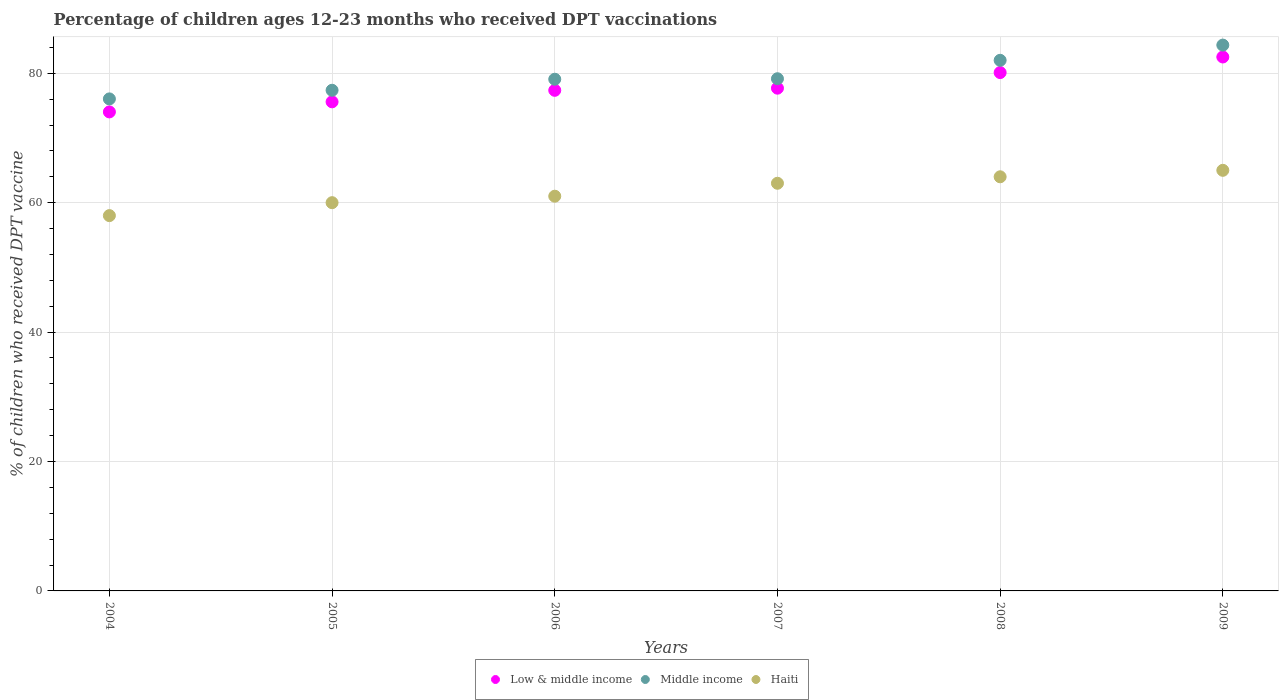What is the percentage of children who received DPT vaccination in Haiti in 2005?
Your response must be concise. 60. Across all years, what is the maximum percentage of children who received DPT vaccination in Middle income?
Your response must be concise. 84.35. Across all years, what is the minimum percentage of children who received DPT vaccination in Low & middle income?
Give a very brief answer. 74.03. In which year was the percentage of children who received DPT vaccination in Low & middle income maximum?
Offer a very short reply. 2009. What is the total percentage of children who received DPT vaccination in Middle income in the graph?
Ensure brevity in your answer.  477.99. What is the difference between the percentage of children who received DPT vaccination in Haiti in 2004 and that in 2007?
Provide a succinct answer. -5. What is the difference between the percentage of children who received DPT vaccination in Middle income in 2004 and the percentage of children who received DPT vaccination in Haiti in 2009?
Offer a very short reply. 11.04. What is the average percentage of children who received DPT vaccination in Middle income per year?
Provide a succinct answer. 79.67. In the year 2004, what is the difference between the percentage of children who received DPT vaccination in Low & middle income and percentage of children who received DPT vaccination in Haiti?
Keep it short and to the point. 16.03. In how many years, is the percentage of children who received DPT vaccination in Haiti greater than 28 %?
Ensure brevity in your answer.  6. What is the ratio of the percentage of children who received DPT vaccination in Low & middle income in 2007 to that in 2009?
Your response must be concise. 0.94. What is the difference between the highest and the lowest percentage of children who received DPT vaccination in Haiti?
Your response must be concise. 7. Is the sum of the percentage of children who received DPT vaccination in Low & middle income in 2004 and 2009 greater than the maximum percentage of children who received DPT vaccination in Middle income across all years?
Your answer should be very brief. Yes. Does the percentage of children who received DPT vaccination in Middle income monotonically increase over the years?
Your answer should be compact. Yes. How many years are there in the graph?
Provide a succinct answer. 6. Are the values on the major ticks of Y-axis written in scientific E-notation?
Give a very brief answer. No. Does the graph contain any zero values?
Keep it short and to the point. No. Where does the legend appear in the graph?
Your answer should be very brief. Bottom center. What is the title of the graph?
Offer a terse response. Percentage of children ages 12-23 months who received DPT vaccinations. Does "New Caledonia" appear as one of the legend labels in the graph?
Provide a short and direct response. No. What is the label or title of the X-axis?
Your answer should be compact. Years. What is the label or title of the Y-axis?
Your response must be concise. % of children who received DPT vaccine. What is the % of children who received DPT vaccine of Low & middle income in 2004?
Keep it short and to the point. 74.03. What is the % of children who received DPT vaccine of Middle income in 2004?
Ensure brevity in your answer.  76.04. What is the % of children who received DPT vaccine of Haiti in 2004?
Offer a very short reply. 58. What is the % of children who received DPT vaccine in Low & middle income in 2005?
Your answer should be compact. 75.58. What is the % of children who received DPT vaccine of Middle income in 2005?
Your answer should be compact. 77.37. What is the % of children who received DPT vaccine of Haiti in 2005?
Offer a very short reply. 60. What is the % of children who received DPT vaccine in Low & middle income in 2006?
Ensure brevity in your answer.  77.36. What is the % of children who received DPT vaccine of Middle income in 2006?
Your response must be concise. 79.08. What is the % of children who received DPT vaccine in Low & middle income in 2007?
Provide a short and direct response. 77.7. What is the % of children who received DPT vaccine in Middle income in 2007?
Give a very brief answer. 79.15. What is the % of children who received DPT vaccine of Low & middle income in 2008?
Keep it short and to the point. 80.11. What is the % of children who received DPT vaccine in Middle income in 2008?
Keep it short and to the point. 82. What is the % of children who received DPT vaccine in Haiti in 2008?
Keep it short and to the point. 64. What is the % of children who received DPT vaccine of Low & middle income in 2009?
Offer a terse response. 82.52. What is the % of children who received DPT vaccine in Middle income in 2009?
Your response must be concise. 84.35. Across all years, what is the maximum % of children who received DPT vaccine in Low & middle income?
Provide a succinct answer. 82.52. Across all years, what is the maximum % of children who received DPT vaccine in Middle income?
Offer a very short reply. 84.35. Across all years, what is the maximum % of children who received DPT vaccine of Haiti?
Make the answer very short. 65. Across all years, what is the minimum % of children who received DPT vaccine in Low & middle income?
Your answer should be very brief. 74.03. Across all years, what is the minimum % of children who received DPT vaccine in Middle income?
Provide a short and direct response. 76.04. What is the total % of children who received DPT vaccine of Low & middle income in the graph?
Give a very brief answer. 467.29. What is the total % of children who received DPT vaccine in Middle income in the graph?
Offer a very short reply. 477.99. What is the total % of children who received DPT vaccine in Haiti in the graph?
Offer a terse response. 371. What is the difference between the % of children who received DPT vaccine of Low & middle income in 2004 and that in 2005?
Keep it short and to the point. -1.56. What is the difference between the % of children who received DPT vaccine of Middle income in 2004 and that in 2005?
Keep it short and to the point. -1.33. What is the difference between the % of children who received DPT vaccine in Low & middle income in 2004 and that in 2006?
Make the answer very short. -3.34. What is the difference between the % of children who received DPT vaccine in Middle income in 2004 and that in 2006?
Give a very brief answer. -3.04. What is the difference between the % of children who received DPT vaccine in Haiti in 2004 and that in 2006?
Offer a very short reply. -3. What is the difference between the % of children who received DPT vaccine of Low & middle income in 2004 and that in 2007?
Keep it short and to the point. -3.67. What is the difference between the % of children who received DPT vaccine of Middle income in 2004 and that in 2007?
Provide a succinct answer. -3.12. What is the difference between the % of children who received DPT vaccine of Low & middle income in 2004 and that in 2008?
Provide a short and direct response. -6.08. What is the difference between the % of children who received DPT vaccine of Middle income in 2004 and that in 2008?
Provide a succinct answer. -5.96. What is the difference between the % of children who received DPT vaccine in Low & middle income in 2004 and that in 2009?
Your answer should be compact. -8.49. What is the difference between the % of children who received DPT vaccine of Middle income in 2004 and that in 2009?
Give a very brief answer. -8.31. What is the difference between the % of children who received DPT vaccine in Low & middle income in 2005 and that in 2006?
Offer a very short reply. -1.78. What is the difference between the % of children who received DPT vaccine of Middle income in 2005 and that in 2006?
Make the answer very short. -1.7. What is the difference between the % of children who received DPT vaccine of Haiti in 2005 and that in 2006?
Your response must be concise. -1. What is the difference between the % of children who received DPT vaccine in Low & middle income in 2005 and that in 2007?
Give a very brief answer. -2.11. What is the difference between the % of children who received DPT vaccine in Middle income in 2005 and that in 2007?
Give a very brief answer. -1.78. What is the difference between the % of children who received DPT vaccine of Low & middle income in 2005 and that in 2008?
Give a very brief answer. -4.52. What is the difference between the % of children who received DPT vaccine of Middle income in 2005 and that in 2008?
Ensure brevity in your answer.  -4.63. What is the difference between the % of children who received DPT vaccine in Haiti in 2005 and that in 2008?
Your answer should be very brief. -4. What is the difference between the % of children who received DPT vaccine in Low & middle income in 2005 and that in 2009?
Your response must be concise. -6.93. What is the difference between the % of children who received DPT vaccine of Middle income in 2005 and that in 2009?
Provide a succinct answer. -6.98. What is the difference between the % of children who received DPT vaccine in Low & middle income in 2006 and that in 2007?
Provide a short and direct response. -0.33. What is the difference between the % of children who received DPT vaccine of Middle income in 2006 and that in 2007?
Your response must be concise. -0.08. What is the difference between the % of children who received DPT vaccine in Low & middle income in 2006 and that in 2008?
Keep it short and to the point. -2.74. What is the difference between the % of children who received DPT vaccine of Middle income in 2006 and that in 2008?
Provide a succinct answer. -2.92. What is the difference between the % of children who received DPT vaccine in Haiti in 2006 and that in 2008?
Give a very brief answer. -3. What is the difference between the % of children who received DPT vaccine of Low & middle income in 2006 and that in 2009?
Ensure brevity in your answer.  -5.15. What is the difference between the % of children who received DPT vaccine of Middle income in 2006 and that in 2009?
Your answer should be very brief. -5.28. What is the difference between the % of children who received DPT vaccine of Low & middle income in 2007 and that in 2008?
Offer a very short reply. -2.41. What is the difference between the % of children who received DPT vaccine in Middle income in 2007 and that in 2008?
Your answer should be compact. -2.85. What is the difference between the % of children who received DPT vaccine of Low & middle income in 2007 and that in 2009?
Keep it short and to the point. -4.82. What is the difference between the % of children who received DPT vaccine in Middle income in 2007 and that in 2009?
Offer a terse response. -5.2. What is the difference between the % of children who received DPT vaccine in Low & middle income in 2008 and that in 2009?
Make the answer very short. -2.41. What is the difference between the % of children who received DPT vaccine of Middle income in 2008 and that in 2009?
Keep it short and to the point. -2.35. What is the difference between the % of children who received DPT vaccine in Low & middle income in 2004 and the % of children who received DPT vaccine in Middle income in 2005?
Your answer should be very brief. -3.35. What is the difference between the % of children who received DPT vaccine of Low & middle income in 2004 and the % of children who received DPT vaccine of Haiti in 2005?
Offer a terse response. 14.03. What is the difference between the % of children who received DPT vaccine of Middle income in 2004 and the % of children who received DPT vaccine of Haiti in 2005?
Provide a short and direct response. 16.04. What is the difference between the % of children who received DPT vaccine of Low & middle income in 2004 and the % of children who received DPT vaccine of Middle income in 2006?
Keep it short and to the point. -5.05. What is the difference between the % of children who received DPT vaccine in Low & middle income in 2004 and the % of children who received DPT vaccine in Haiti in 2006?
Offer a very short reply. 13.03. What is the difference between the % of children who received DPT vaccine in Middle income in 2004 and the % of children who received DPT vaccine in Haiti in 2006?
Your answer should be very brief. 15.04. What is the difference between the % of children who received DPT vaccine of Low & middle income in 2004 and the % of children who received DPT vaccine of Middle income in 2007?
Ensure brevity in your answer.  -5.13. What is the difference between the % of children who received DPT vaccine of Low & middle income in 2004 and the % of children who received DPT vaccine of Haiti in 2007?
Ensure brevity in your answer.  11.03. What is the difference between the % of children who received DPT vaccine of Middle income in 2004 and the % of children who received DPT vaccine of Haiti in 2007?
Offer a very short reply. 13.04. What is the difference between the % of children who received DPT vaccine of Low & middle income in 2004 and the % of children who received DPT vaccine of Middle income in 2008?
Offer a terse response. -7.97. What is the difference between the % of children who received DPT vaccine in Low & middle income in 2004 and the % of children who received DPT vaccine in Haiti in 2008?
Offer a terse response. 10.03. What is the difference between the % of children who received DPT vaccine in Middle income in 2004 and the % of children who received DPT vaccine in Haiti in 2008?
Keep it short and to the point. 12.04. What is the difference between the % of children who received DPT vaccine in Low & middle income in 2004 and the % of children who received DPT vaccine in Middle income in 2009?
Offer a terse response. -10.33. What is the difference between the % of children who received DPT vaccine of Low & middle income in 2004 and the % of children who received DPT vaccine of Haiti in 2009?
Give a very brief answer. 9.03. What is the difference between the % of children who received DPT vaccine in Middle income in 2004 and the % of children who received DPT vaccine in Haiti in 2009?
Give a very brief answer. 11.04. What is the difference between the % of children who received DPT vaccine in Low & middle income in 2005 and the % of children who received DPT vaccine in Middle income in 2006?
Make the answer very short. -3.49. What is the difference between the % of children who received DPT vaccine of Low & middle income in 2005 and the % of children who received DPT vaccine of Haiti in 2006?
Your response must be concise. 14.58. What is the difference between the % of children who received DPT vaccine in Middle income in 2005 and the % of children who received DPT vaccine in Haiti in 2006?
Offer a terse response. 16.37. What is the difference between the % of children who received DPT vaccine of Low & middle income in 2005 and the % of children who received DPT vaccine of Middle income in 2007?
Your response must be concise. -3.57. What is the difference between the % of children who received DPT vaccine of Low & middle income in 2005 and the % of children who received DPT vaccine of Haiti in 2007?
Provide a succinct answer. 12.58. What is the difference between the % of children who received DPT vaccine of Middle income in 2005 and the % of children who received DPT vaccine of Haiti in 2007?
Offer a very short reply. 14.37. What is the difference between the % of children who received DPT vaccine of Low & middle income in 2005 and the % of children who received DPT vaccine of Middle income in 2008?
Offer a very short reply. -6.42. What is the difference between the % of children who received DPT vaccine of Low & middle income in 2005 and the % of children who received DPT vaccine of Haiti in 2008?
Offer a very short reply. 11.58. What is the difference between the % of children who received DPT vaccine of Middle income in 2005 and the % of children who received DPT vaccine of Haiti in 2008?
Your answer should be very brief. 13.37. What is the difference between the % of children who received DPT vaccine in Low & middle income in 2005 and the % of children who received DPT vaccine in Middle income in 2009?
Provide a short and direct response. -8.77. What is the difference between the % of children who received DPT vaccine of Low & middle income in 2005 and the % of children who received DPT vaccine of Haiti in 2009?
Provide a succinct answer. 10.58. What is the difference between the % of children who received DPT vaccine in Middle income in 2005 and the % of children who received DPT vaccine in Haiti in 2009?
Ensure brevity in your answer.  12.37. What is the difference between the % of children who received DPT vaccine of Low & middle income in 2006 and the % of children who received DPT vaccine of Middle income in 2007?
Give a very brief answer. -1.79. What is the difference between the % of children who received DPT vaccine of Low & middle income in 2006 and the % of children who received DPT vaccine of Haiti in 2007?
Give a very brief answer. 14.36. What is the difference between the % of children who received DPT vaccine of Middle income in 2006 and the % of children who received DPT vaccine of Haiti in 2007?
Your response must be concise. 16.08. What is the difference between the % of children who received DPT vaccine of Low & middle income in 2006 and the % of children who received DPT vaccine of Middle income in 2008?
Provide a succinct answer. -4.64. What is the difference between the % of children who received DPT vaccine in Low & middle income in 2006 and the % of children who received DPT vaccine in Haiti in 2008?
Provide a short and direct response. 13.36. What is the difference between the % of children who received DPT vaccine in Middle income in 2006 and the % of children who received DPT vaccine in Haiti in 2008?
Offer a very short reply. 15.08. What is the difference between the % of children who received DPT vaccine in Low & middle income in 2006 and the % of children who received DPT vaccine in Middle income in 2009?
Provide a short and direct response. -6.99. What is the difference between the % of children who received DPT vaccine of Low & middle income in 2006 and the % of children who received DPT vaccine of Haiti in 2009?
Provide a succinct answer. 12.36. What is the difference between the % of children who received DPT vaccine of Middle income in 2006 and the % of children who received DPT vaccine of Haiti in 2009?
Offer a terse response. 14.08. What is the difference between the % of children who received DPT vaccine of Low & middle income in 2007 and the % of children who received DPT vaccine of Middle income in 2008?
Provide a short and direct response. -4.31. What is the difference between the % of children who received DPT vaccine in Low & middle income in 2007 and the % of children who received DPT vaccine in Haiti in 2008?
Make the answer very short. 13.7. What is the difference between the % of children who received DPT vaccine in Middle income in 2007 and the % of children who received DPT vaccine in Haiti in 2008?
Offer a very short reply. 15.15. What is the difference between the % of children who received DPT vaccine in Low & middle income in 2007 and the % of children who received DPT vaccine in Middle income in 2009?
Your answer should be very brief. -6.66. What is the difference between the % of children who received DPT vaccine of Low & middle income in 2007 and the % of children who received DPT vaccine of Haiti in 2009?
Provide a succinct answer. 12.7. What is the difference between the % of children who received DPT vaccine of Middle income in 2007 and the % of children who received DPT vaccine of Haiti in 2009?
Keep it short and to the point. 14.15. What is the difference between the % of children who received DPT vaccine in Low & middle income in 2008 and the % of children who received DPT vaccine in Middle income in 2009?
Offer a terse response. -4.24. What is the difference between the % of children who received DPT vaccine of Low & middle income in 2008 and the % of children who received DPT vaccine of Haiti in 2009?
Provide a succinct answer. 15.11. What is the difference between the % of children who received DPT vaccine of Middle income in 2008 and the % of children who received DPT vaccine of Haiti in 2009?
Keep it short and to the point. 17. What is the average % of children who received DPT vaccine in Low & middle income per year?
Keep it short and to the point. 77.88. What is the average % of children who received DPT vaccine in Middle income per year?
Your response must be concise. 79.67. What is the average % of children who received DPT vaccine in Haiti per year?
Your response must be concise. 61.83. In the year 2004, what is the difference between the % of children who received DPT vaccine of Low & middle income and % of children who received DPT vaccine of Middle income?
Make the answer very short. -2.01. In the year 2004, what is the difference between the % of children who received DPT vaccine of Low & middle income and % of children who received DPT vaccine of Haiti?
Make the answer very short. 16.03. In the year 2004, what is the difference between the % of children who received DPT vaccine in Middle income and % of children who received DPT vaccine in Haiti?
Provide a succinct answer. 18.04. In the year 2005, what is the difference between the % of children who received DPT vaccine of Low & middle income and % of children who received DPT vaccine of Middle income?
Make the answer very short. -1.79. In the year 2005, what is the difference between the % of children who received DPT vaccine of Low & middle income and % of children who received DPT vaccine of Haiti?
Make the answer very short. 15.58. In the year 2005, what is the difference between the % of children who received DPT vaccine of Middle income and % of children who received DPT vaccine of Haiti?
Make the answer very short. 17.37. In the year 2006, what is the difference between the % of children who received DPT vaccine of Low & middle income and % of children who received DPT vaccine of Middle income?
Your response must be concise. -1.71. In the year 2006, what is the difference between the % of children who received DPT vaccine of Low & middle income and % of children who received DPT vaccine of Haiti?
Give a very brief answer. 16.36. In the year 2006, what is the difference between the % of children who received DPT vaccine in Middle income and % of children who received DPT vaccine in Haiti?
Ensure brevity in your answer.  18.08. In the year 2007, what is the difference between the % of children who received DPT vaccine of Low & middle income and % of children who received DPT vaccine of Middle income?
Ensure brevity in your answer.  -1.46. In the year 2007, what is the difference between the % of children who received DPT vaccine of Low & middle income and % of children who received DPT vaccine of Haiti?
Give a very brief answer. 14.7. In the year 2007, what is the difference between the % of children who received DPT vaccine of Middle income and % of children who received DPT vaccine of Haiti?
Give a very brief answer. 16.15. In the year 2008, what is the difference between the % of children who received DPT vaccine in Low & middle income and % of children who received DPT vaccine in Middle income?
Your answer should be compact. -1.89. In the year 2008, what is the difference between the % of children who received DPT vaccine in Low & middle income and % of children who received DPT vaccine in Haiti?
Offer a terse response. 16.11. In the year 2008, what is the difference between the % of children who received DPT vaccine of Middle income and % of children who received DPT vaccine of Haiti?
Offer a terse response. 18. In the year 2009, what is the difference between the % of children who received DPT vaccine of Low & middle income and % of children who received DPT vaccine of Middle income?
Provide a short and direct response. -1.84. In the year 2009, what is the difference between the % of children who received DPT vaccine of Low & middle income and % of children who received DPT vaccine of Haiti?
Offer a very short reply. 17.52. In the year 2009, what is the difference between the % of children who received DPT vaccine of Middle income and % of children who received DPT vaccine of Haiti?
Offer a very short reply. 19.35. What is the ratio of the % of children who received DPT vaccine in Low & middle income in 2004 to that in 2005?
Give a very brief answer. 0.98. What is the ratio of the % of children who received DPT vaccine of Middle income in 2004 to that in 2005?
Keep it short and to the point. 0.98. What is the ratio of the % of children who received DPT vaccine in Haiti in 2004 to that in 2005?
Your response must be concise. 0.97. What is the ratio of the % of children who received DPT vaccine in Low & middle income in 2004 to that in 2006?
Provide a succinct answer. 0.96. What is the ratio of the % of children who received DPT vaccine of Middle income in 2004 to that in 2006?
Ensure brevity in your answer.  0.96. What is the ratio of the % of children who received DPT vaccine in Haiti in 2004 to that in 2006?
Provide a short and direct response. 0.95. What is the ratio of the % of children who received DPT vaccine of Low & middle income in 2004 to that in 2007?
Your answer should be very brief. 0.95. What is the ratio of the % of children who received DPT vaccine in Middle income in 2004 to that in 2007?
Make the answer very short. 0.96. What is the ratio of the % of children who received DPT vaccine of Haiti in 2004 to that in 2007?
Make the answer very short. 0.92. What is the ratio of the % of children who received DPT vaccine of Low & middle income in 2004 to that in 2008?
Ensure brevity in your answer.  0.92. What is the ratio of the % of children who received DPT vaccine in Middle income in 2004 to that in 2008?
Ensure brevity in your answer.  0.93. What is the ratio of the % of children who received DPT vaccine in Haiti in 2004 to that in 2008?
Provide a succinct answer. 0.91. What is the ratio of the % of children who received DPT vaccine in Low & middle income in 2004 to that in 2009?
Your answer should be very brief. 0.9. What is the ratio of the % of children who received DPT vaccine in Middle income in 2004 to that in 2009?
Your answer should be very brief. 0.9. What is the ratio of the % of children who received DPT vaccine of Haiti in 2004 to that in 2009?
Ensure brevity in your answer.  0.89. What is the ratio of the % of children who received DPT vaccine of Low & middle income in 2005 to that in 2006?
Provide a succinct answer. 0.98. What is the ratio of the % of children who received DPT vaccine of Middle income in 2005 to that in 2006?
Your answer should be compact. 0.98. What is the ratio of the % of children who received DPT vaccine of Haiti in 2005 to that in 2006?
Your response must be concise. 0.98. What is the ratio of the % of children who received DPT vaccine of Low & middle income in 2005 to that in 2007?
Provide a short and direct response. 0.97. What is the ratio of the % of children who received DPT vaccine of Middle income in 2005 to that in 2007?
Ensure brevity in your answer.  0.98. What is the ratio of the % of children who received DPT vaccine of Low & middle income in 2005 to that in 2008?
Keep it short and to the point. 0.94. What is the ratio of the % of children who received DPT vaccine in Middle income in 2005 to that in 2008?
Make the answer very short. 0.94. What is the ratio of the % of children who received DPT vaccine in Low & middle income in 2005 to that in 2009?
Ensure brevity in your answer.  0.92. What is the ratio of the % of children who received DPT vaccine of Middle income in 2005 to that in 2009?
Provide a succinct answer. 0.92. What is the ratio of the % of children who received DPT vaccine in Middle income in 2006 to that in 2007?
Keep it short and to the point. 1. What is the ratio of the % of children who received DPT vaccine of Haiti in 2006 to that in 2007?
Keep it short and to the point. 0.97. What is the ratio of the % of children who received DPT vaccine of Low & middle income in 2006 to that in 2008?
Provide a short and direct response. 0.97. What is the ratio of the % of children who received DPT vaccine of Middle income in 2006 to that in 2008?
Your answer should be compact. 0.96. What is the ratio of the % of children who received DPT vaccine of Haiti in 2006 to that in 2008?
Offer a very short reply. 0.95. What is the ratio of the % of children who received DPT vaccine in Low & middle income in 2006 to that in 2009?
Your response must be concise. 0.94. What is the ratio of the % of children who received DPT vaccine of Haiti in 2006 to that in 2009?
Your answer should be compact. 0.94. What is the ratio of the % of children who received DPT vaccine in Low & middle income in 2007 to that in 2008?
Keep it short and to the point. 0.97. What is the ratio of the % of children who received DPT vaccine in Middle income in 2007 to that in 2008?
Provide a succinct answer. 0.97. What is the ratio of the % of children who received DPT vaccine in Haiti in 2007 to that in 2008?
Offer a very short reply. 0.98. What is the ratio of the % of children who received DPT vaccine in Low & middle income in 2007 to that in 2009?
Give a very brief answer. 0.94. What is the ratio of the % of children who received DPT vaccine of Middle income in 2007 to that in 2009?
Ensure brevity in your answer.  0.94. What is the ratio of the % of children who received DPT vaccine of Haiti in 2007 to that in 2009?
Give a very brief answer. 0.97. What is the ratio of the % of children who received DPT vaccine of Low & middle income in 2008 to that in 2009?
Offer a terse response. 0.97. What is the ratio of the % of children who received DPT vaccine of Middle income in 2008 to that in 2009?
Offer a terse response. 0.97. What is the ratio of the % of children who received DPT vaccine of Haiti in 2008 to that in 2009?
Your answer should be compact. 0.98. What is the difference between the highest and the second highest % of children who received DPT vaccine in Low & middle income?
Keep it short and to the point. 2.41. What is the difference between the highest and the second highest % of children who received DPT vaccine of Middle income?
Make the answer very short. 2.35. What is the difference between the highest and the second highest % of children who received DPT vaccine in Haiti?
Your response must be concise. 1. What is the difference between the highest and the lowest % of children who received DPT vaccine in Low & middle income?
Ensure brevity in your answer.  8.49. What is the difference between the highest and the lowest % of children who received DPT vaccine in Middle income?
Provide a short and direct response. 8.31. What is the difference between the highest and the lowest % of children who received DPT vaccine of Haiti?
Offer a terse response. 7. 